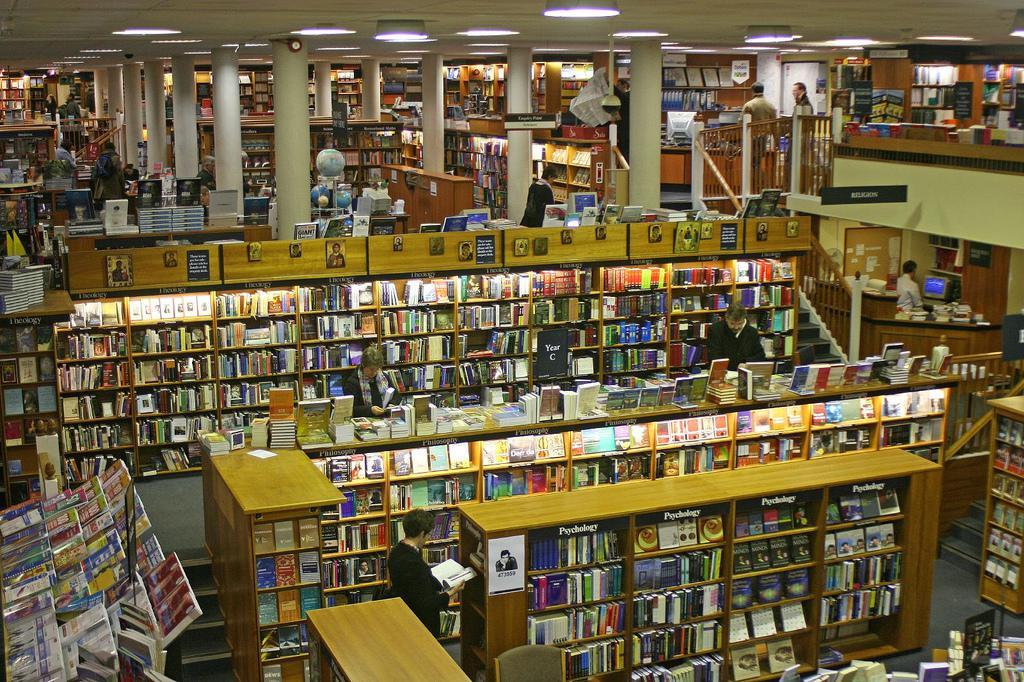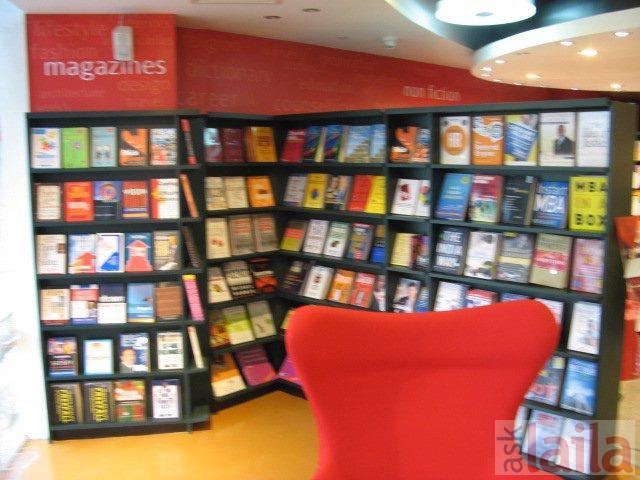The first image is the image on the left, the second image is the image on the right. Considering the images on both sides, is "One image is a bookstore interior featuring bright red-orange on the wall above black bookshelves, and a sculptural red-orange furniture piece in front of the shelves." valid? Answer yes or no. Yes. The first image is the image on the left, the second image is the image on the right. Examine the images to the left and right. Is the description "the book store is being viewed from the second floor" accurate? Answer yes or no. Yes. 